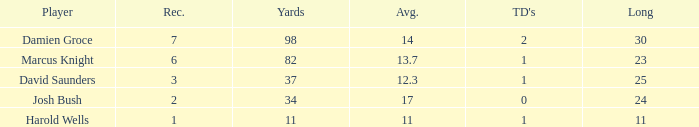How many TDs are there were the long is smaller than 23? 1.0. 